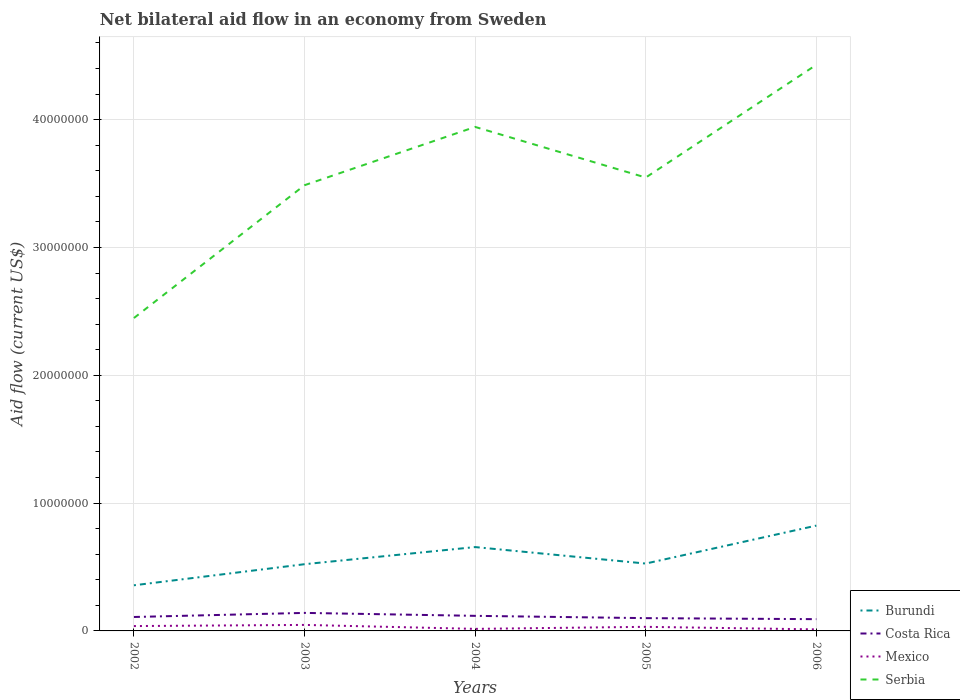Does the line corresponding to Serbia intersect with the line corresponding to Costa Rica?
Your answer should be compact. No. Is the number of lines equal to the number of legend labels?
Keep it short and to the point. Yes. Across all years, what is the maximum net bilateral aid flow in Costa Rica?
Offer a terse response. 9.20e+05. What is the total net bilateral aid flow in Mexico in the graph?
Offer a terse response. 4.00e+04. What is the difference between the highest and the second highest net bilateral aid flow in Mexico?
Offer a terse response. 3.50e+05. Is the net bilateral aid flow in Burundi strictly greater than the net bilateral aid flow in Serbia over the years?
Give a very brief answer. Yes. What is the difference between two consecutive major ticks on the Y-axis?
Make the answer very short. 1.00e+07. Does the graph contain grids?
Your response must be concise. Yes. Where does the legend appear in the graph?
Make the answer very short. Bottom right. What is the title of the graph?
Make the answer very short. Net bilateral aid flow in an economy from Sweden. Does "Central Europe" appear as one of the legend labels in the graph?
Provide a succinct answer. No. What is the Aid flow (current US$) of Burundi in 2002?
Your response must be concise. 3.57e+06. What is the Aid flow (current US$) in Costa Rica in 2002?
Ensure brevity in your answer.  1.09e+06. What is the Aid flow (current US$) in Serbia in 2002?
Provide a short and direct response. 2.45e+07. What is the Aid flow (current US$) of Burundi in 2003?
Your answer should be very brief. 5.22e+06. What is the Aid flow (current US$) of Costa Rica in 2003?
Give a very brief answer. 1.41e+06. What is the Aid flow (current US$) of Mexico in 2003?
Your answer should be compact. 4.70e+05. What is the Aid flow (current US$) of Serbia in 2003?
Provide a short and direct response. 3.49e+07. What is the Aid flow (current US$) of Burundi in 2004?
Keep it short and to the point. 6.56e+06. What is the Aid flow (current US$) in Costa Rica in 2004?
Provide a short and direct response. 1.18e+06. What is the Aid flow (current US$) in Serbia in 2004?
Ensure brevity in your answer.  3.94e+07. What is the Aid flow (current US$) of Burundi in 2005?
Your answer should be compact. 5.27e+06. What is the Aid flow (current US$) in Costa Rica in 2005?
Keep it short and to the point. 1.00e+06. What is the Aid flow (current US$) of Serbia in 2005?
Provide a short and direct response. 3.55e+07. What is the Aid flow (current US$) of Burundi in 2006?
Your answer should be compact. 8.24e+06. What is the Aid flow (current US$) in Costa Rica in 2006?
Your response must be concise. 9.20e+05. What is the Aid flow (current US$) of Serbia in 2006?
Your answer should be compact. 4.43e+07. Across all years, what is the maximum Aid flow (current US$) in Burundi?
Offer a terse response. 8.24e+06. Across all years, what is the maximum Aid flow (current US$) in Costa Rica?
Your answer should be compact. 1.41e+06. Across all years, what is the maximum Aid flow (current US$) of Mexico?
Your answer should be very brief. 4.70e+05. Across all years, what is the maximum Aid flow (current US$) of Serbia?
Your answer should be compact. 4.43e+07. Across all years, what is the minimum Aid flow (current US$) in Burundi?
Provide a succinct answer. 3.57e+06. Across all years, what is the minimum Aid flow (current US$) of Costa Rica?
Make the answer very short. 9.20e+05. Across all years, what is the minimum Aid flow (current US$) of Mexico?
Your response must be concise. 1.20e+05. Across all years, what is the minimum Aid flow (current US$) in Serbia?
Your answer should be very brief. 2.45e+07. What is the total Aid flow (current US$) of Burundi in the graph?
Give a very brief answer. 2.89e+07. What is the total Aid flow (current US$) of Costa Rica in the graph?
Offer a very short reply. 5.60e+06. What is the total Aid flow (current US$) in Mexico in the graph?
Offer a very short reply. 1.45e+06. What is the total Aid flow (current US$) of Serbia in the graph?
Offer a very short reply. 1.79e+08. What is the difference between the Aid flow (current US$) of Burundi in 2002 and that in 2003?
Your response must be concise. -1.65e+06. What is the difference between the Aid flow (current US$) in Costa Rica in 2002 and that in 2003?
Keep it short and to the point. -3.20e+05. What is the difference between the Aid flow (current US$) in Mexico in 2002 and that in 2003?
Provide a short and direct response. -9.00e+04. What is the difference between the Aid flow (current US$) in Serbia in 2002 and that in 2003?
Provide a succinct answer. -1.04e+07. What is the difference between the Aid flow (current US$) in Burundi in 2002 and that in 2004?
Your response must be concise. -2.99e+06. What is the difference between the Aid flow (current US$) of Costa Rica in 2002 and that in 2004?
Your response must be concise. -9.00e+04. What is the difference between the Aid flow (current US$) of Serbia in 2002 and that in 2004?
Ensure brevity in your answer.  -1.50e+07. What is the difference between the Aid flow (current US$) in Burundi in 2002 and that in 2005?
Offer a terse response. -1.70e+06. What is the difference between the Aid flow (current US$) of Serbia in 2002 and that in 2005?
Ensure brevity in your answer.  -1.10e+07. What is the difference between the Aid flow (current US$) of Burundi in 2002 and that in 2006?
Offer a very short reply. -4.67e+06. What is the difference between the Aid flow (current US$) in Mexico in 2002 and that in 2006?
Make the answer very short. 2.60e+05. What is the difference between the Aid flow (current US$) in Serbia in 2002 and that in 2006?
Provide a short and direct response. -1.98e+07. What is the difference between the Aid flow (current US$) of Burundi in 2003 and that in 2004?
Your answer should be compact. -1.34e+06. What is the difference between the Aid flow (current US$) in Mexico in 2003 and that in 2004?
Your response must be concise. 3.10e+05. What is the difference between the Aid flow (current US$) in Serbia in 2003 and that in 2004?
Give a very brief answer. -4.56e+06. What is the difference between the Aid flow (current US$) in Burundi in 2003 and that in 2005?
Your answer should be very brief. -5.00e+04. What is the difference between the Aid flow (current US$) of Serbia in 2003 and that in 2005?
Keep it short and to the point. -6.00e+05. What is the difference between the Aid flow (current US$) in Burundi in 2003 and that in 2006?
Make the answer very short. -3.02e+06. What is the difference between the Aid flow (current US$) in Serbia in 2003 and that in 2006?
Your response must be concise. -9.42e+06. What is the difference between the Aid flow (current US$) in Burundi in 2004 and that in 2005?
Ensure brevity in your answer.  1.29e+06. What is the difference between the Aid flow (current US$) of Mexico in 2004 and that in 2005?
Your answer should be compact. -1.60e+05. What is the difference between the Aid flow (current US$) of Serbia in 2004 and that in 2005?
Give a very brief answer. 3.96e+06. What is the difference between the Aid flow (current US$) in Burundi in 2004 and that in 2006?
Provide a short and direct response. -1.68e+06. What is the difference between the Aid flow (current US$) in Serbia in 2004 and that in 2006?
Give a very brief answer. -4.86e+06. What is the difference between the Aid flow (current US$) of Burundi in 2005 and that in 2006?
Your response must be concise. -2.97e+06. What is the difference between the Aid flow (current US$) in Mexico in 2005 and that in 2006?
Make the answer very short. 2.00e+05. What is the difference between the Aid flow (current US$) of Serbia in 2005 and that in 2006?
Offer a terse response. -8.82e+06. What is the difference between the Aid flow (current US$) of Burundi in 2002 and the Aid flow (current US$) of Costa Rica in 2003?
Your answer should be very brief. 2.16e+06. What is the difference between the Aid flow (current US$) in Burundi in 2002 and the Aid flow (current US$) in Mexico in 2003?
Provide a succinct answer. 3.10e+06. What is the difference between the Aid flow (current US$) in Burundi in 2002 and the Aid flow (current US$) in Serbia in 2003?
Your response must be concise. -3.13e+07. What is the difference between the Aid flow (current US$) in Costa Rica in 2002 and the Aid flow (current US$) in Mexico in 2003?
Your answer should be very brief. 6.20e+05. What is the difference between the Aid flow (current US$) in Costa Rica in 2002 and the Aid flow (current US$) in Serbia in 2003?
Give a very brief answer. -3.38e+07. What is the difference between the Aid flow (current US$) in Mexico in 2002 and the Aid flow (current US$) in Serbia in 2003?
Provide a succinct answer. -3.45e+07. What is the difference between the Aid flow (current US$) of Burundi in 2002 and the Aid flow (current US$) of Costa Rica in 2004?
Make the answer very short. 2.39e+06. What is the difference between the Aid flow (current US$) of Burundi in 2002 and the Aid flow (current US$) of Mexico in 2004?
Ensure brevity in your answer.  3.41e+06. What is the difference between the Aid flow (current US$) in Burundi in 2002 and the Aid flow (current US$) in Serbia in 2004?
Provide a succinct answer. -3.59e+07. What is the difference between the Aid flow (current US$) of Costa Rica in 2002 and the Aid flow (current US$) of Mexico in 2004?
Offer a terse response. 9.30e+05. What is the difference between the Aid flow (current US$) of Costa Rica in 2002 and the Aid flow (current US$) of Serbia in 2004?
Provide a short and direct response. -3.83e+07. What is the difference between the Aid flow (current US$) in Mexico in 2002 and the Aid flow (current US$) in Serbia in 2004?
Your answer should be compact. -3.90e+07. What is the difference between the Aid flow (current US$) in Burundi in 2002 and the Aid flow (current US$) in Costa Rica in 2005?
Your answer should be compact. 2.57e+06. What is the difference between the Aid flow (current US$) in Burundi in 2002 and the Aid flow (current US$) in Mexico in 2005?
Make the answer very short. 3.25e+06. What is the difference between the Aid flow (current US$) of Burundi in 2002 and the Aid flow (current US$) of Serbia in 2005?
Ensure brevity in your answer.  -3.19e+07. What is the difference between the Aid flow (current US$) of Costa Rica in 2002 and the Aid flow (current US$) of Mexico in 2005?
Provide a succinct answer. 7.70e+05. What is the difference between the Aid flow (current US$) of Costa Rica in 2002 and the Aid flow (current US$) of Serbia in 2005?
Offer a very short reply. -3.44e+07. What is the difference between the Aid flow (current US$) in Mexico in 2002 and the Aid flow (current US$) in Serbia in 2005?
Offer a terse response. -3.51e+07. What is the difference between the Aid flow (current US$) of Burundi in 2002 and the Aid flow (current US$) of Costa Rica in 2006?
Offer a terse response. 2.65e+06. What is the difference between the Aid flow (current US$) of Burundi in 2002 and the Aid flow (current US$) of Mexico in 2006?
Provide a short and direct response. 3.45e+06. What is the difference between the Aid flow (current US$) of Burundi in 2002 and the Aid flow (current US$) of Serbia in 2006?
Offer a very short reply. -4.07e+07. What is the difference between the Aid flow (current US$) of Costa Rica in 2002 and the Aid flow (current US$) of Mexico in 2006?
Your answer should be very brief. 9.70e+05. What is the difference between the Aid flow (current US$) of Costa Rica in 2002 and the Aid flow (current US$) of Serbia in 2006?
Make the answer very short. -4.32e+07. What is the difference between the Aid flow (current US$) in Mexico in 2002 and the Aid flow (current US$) in Serbia in 2006?
Offer a terse response. -4.39e+07. What is the difference between the Aid flow (current US$) in Burundi in 2003 and the Aid flow (current US$) in Costa Rica in 2004?
Give a very brief answer. 4.04e+06. What is the difference between the Aid flow (current US$) in Burundi in 2003 and the Aid flow (current US$) in Mexico in 2004?
Your answer should be very brief. 5.06e+06. What is the difference between the Aid flow (current US$) of Burundi in 2003 and the Aid flow (current US$) of Serbia in 2004?
Your answer should be very brief. -3.42e+07. What is the difference between the Aid flow (current US$) of Costa Rica in 2003 and the Aid flow (current US$) of Mexico in 2004?
Provide a short and direct response. 1.25e+06. What is the difference between the Aid flow (current US$) in Costa Rica in 2003 and the Aid flow (current US$) in Serbia in 2004?
Make the answer very short. -3.80e+07. What is the difference between the Aid flow (current US$) of Mexico in 2003 and the Aid flow (current US$) of Serbia in 2004?
Your response must be concise. -3.90e+07. What is the difference between the Aid flow (current US$) of Burundi in 2003 and the Aid flow (current US$) of Costa Rica in 2005?
Ensure brevity in your answer.  4.22e+06. What is the difference between the Aid flow (current US$) in Burundi in 2003 and the Aid flow (current US$) in Mexico in 2005?
Your answer should be compact. 4.90e+06. What is the difference between the Aid flow (current US$) in Burundi in 2003 and the Aid flow (current US$) in Serbia in 2005?
Make the answer very short. -3.02e+07. What is the difference between the Aid flow (current US$) of Costa Rica in 2003 and the Aid flow (current US$) of Mexico in 2005?
Provide a succinct answer. 1.09e+06. What is the difference between the Aid flow (current US$) of Costa Rica in 2003 and the Aid flow (current US$) of Serbia in 2005?
Give a very brief answer. -3.41e+07. What is the difference between the Aid flow (current US$) in Mexico in 2003 and the Aid flow (current US$) in Serbia in 2005?
Provide a short and direct response. -3.50e+07. What is the difference between the Aid flow (current US$) in Burundi in 2003 and the Aid flow (current US$) in Costa Rica in 2006?
Keep it short and to the point. 4.30e+06. What is the difference between the Aid flow (current US$) of Burundi in 2003 and the Aid flow (current US$) of Mexico in 2006?
Your answer should be very brief. 5.10e+06. What is the difference between the Aid flow (current US$) in Burundi in 2003 and the Aid flow (current US$) in Serbia in 2006?
Provide a short and direct response. -3.91e+07. What is the difference between the Aid flow (current US$) in Costa Rica in 2003 and the Aid flow (current US$) in Mexico in 2006?
Your answer should be compact. 1.29e+06. What is the difference between the Aid flow (current US$) in Costa Rica in 2003 and the Aid flow (current US$) in Serbia in 2006?
Ensure brevity in your answer.  -4.29e+07. What is the difference between the Aid flow (current US$) of Mexico in 2003 and the Aid flow (current US$) of Serbia in 2006?
Offer a terse response. -4.38e+07. What is the difference between the Aid flow (current US$) in Burundi in 2004 and the Aid flow (current US$) in Costa Rica in 2005?
Offer a very short reply. 5.56e+06. What is the difference between the Aid flow (current US$) in Burundi in 2004 and the Aid flow (current US$) in Mexico in 2005?
Give a very brief answer. 6.24e+06. What is the difference between the Aid flow (current US$) in Burundi in 2004 and the Aid flow (current US$) in Serbia in 2005?
Your answer should be compact. -2.89e+07. What is the difference between the Aid flow (current US$) in Costa Rica in 2004 and the Aid flow (current US$) in Mexico in 2005?
Provide a succinct answer. 8.60e+05. What is the difference between the Aid flow (current US$) in Costa Rica in 2004 and the Aid flow (current US$) in Serbia in 2005?
Your response must be concise. -3.43e+07. What is the difference between the Aid flow (current US$) of Mexico in 2004 and the Aid flow (current US$) of Serbia in 2005?
Provide a short and direct response. -3.53e+07. What is the difference between the Aid flow (current US$) in Burundi in 2004 and the Aid flow (current US$) in Costa Rica in 2006?
Your response must be concise. 5.64e+06. What is the difference between the Aid flow (current US$) in Burundi in 2004 and the Aid flow (current US$) in Mexico in 2006?
Your response must be concise. 6.44e+06. What is the difference between the Aid flow (current US$) of Burundi in 2004 and the Aid flow (current US$) of Serbia in 2006?
Keep it short and to the point. -3.77e+07. What is the difference between the Aid flow (current US$) in Costa Rica in 2004 and the Aid flow (current US$) in Mexico in 2006?
Provide a short and direct response. 1.06e+06. What is the difference between the Aid flow (current US$) of Costa Rica in 2004 and the Aid flow (current US$) of Serbia in 2006?
Offer a terse response. -4.31e+07. What is the difference between the Aid flow (current US$) in Mexico in 2004 and the Aid flow (current US$) in Serbia in 2006?
Your answer should be very brief. -4.41e+07. What is the difference between the Aid flow (current US$) in Burundi in 2005 and the Aid flow (current US$) in Costa Rica in 2006?
Your answer should be compact. 4.35e+06. What is the difference between the Aid flow (current US$) of Burundi in 2005 and the Aid flow (current US$) of Mexico in 2006?
Your response must be concise. 5.15e+06. What is the difference between the Aid flow (current US$) of Burundi in 2005 and the Aid flow (current US$) of Serbia in 2006?
Make the answer very short. -3.90e+07. What is the difference between the Aid flow (current US$) in Costa Rica in 2005 and the Aid flow (current US$) in Mexico in 2006?
Offer a terse response. 8.80e+05. What is the difference between the Aid flow (current US$) of Costa Rica in 2005 and the Aid flow (current US$) of Serbia in 2006?
Your response must be concise. -4.33e+07. What is the difference between the Aid flow (current US$) in Mexico in 2005 and the Aid flow (current US$) in Serbia in 2006?
Provide a succinct answer. -4.40e+07. What is the average Aid flow (current US$) of Burundi per year?
Make the answer very short. 5.77e+06. What is the average Aid flow (current US$) of Costa Rica per year?
Offer a very short reply. 1.12e+06. What is the average Aid flow (current US$) in Serbia per year?
Your answer should be very brief. 3.57e+07. In the year 2002, what is the difference between the Aid flow (current US$) in Burundi and Aid flow (current US$) in Costa Rica?
Your response must be concise. 2.48e+06. In the year 2002, what is the difference between the Aid flow (current US$) in Burundi and Aid flow (current US$) in Mexico?
Provide a short and direct response. 3.19e+06. In the year 2002, what is the difference between the Aid flow (current US$) of Burundi and Aid flow (current US$) of Serbia?
Your answer should be very brief. -2.09e+07. In the year 2002, what is the difference between the Aid flow (current US$) in Costa Rica and Aid flow (current US$) in Mexico?
Provide a succinct answer. 7.10e+05. In the year 2002, what is the difference between the Aid flow (current US$) in Costa Rica and Aid flow (current US$) in Serbia?
Ensure brevity in your answer.  -2.34e+07. In the year 2002, what is the difference between the Aid flow (current US$) of Mexico and Aid flow (current US$) of Serbia?
Offer a terse response. -2.41e+07. In the year 2003, what is the difference between the Aid flow (current US$) in Burundi and Aid flow (current US$) in Costa Rica?
Your response must be concise. 3.81e+06. In the year 2003, what is the difference between the Aid flow (current US$) of Burundi and Aid flow (current US$) of Mexico?
Offer a very short reply. 4.75e+06. In the year 2003, what is the difference between the Aid flow (current US$) of Burundi and Aid flow (current US$) of Serbia?
Your answer should be very brief. -2.96e+07. In the year 2003, what is the difference between the Aid flow (current US$) in Costa Rica and Aid flow (current US$) in Mexico?
Give a very brief answer. 9.40e+05. In the year 2003, what is the difference between the Aid flow (current US$) of Costa Rica and Aid flow (current US$) of Serbia?
Provide a succinct answer. -3.35e+07. In the year 2003, what is the difference between the Aid flow (current US$) in Mexico and Aid flow (current US$) in Serbia?
Your answer should be compact. -3.44e+07. In the year 2004, what is the difference between the Aid flow (current US$) of Burundi and Aid flow (current US$) of Costa Rica?
Offer a terse response. 5.38e+06. In the year 2004, what is the difference between the Aid flow (current US$) in Burundi and Aid flow (current US$) in Mexico?
Your response must be concise. 6.40e+06. In the year 2004, what is the difference between the Aid flow (current US$) of Burundi and Aid flow (current US$) of Serbia?
Provide a short and direct response. -3.29e+07. In the year 2004, what is the difference between the Aid flow (current US$) in Costa Rica and Aid flow (current US$) in Mexico?
Provide a succinct answer. 1.02e+06. In the year 2004, what is the difference between the Aid flow (current US$) in Costa Rica and Aid flow (current US$) in Serbia?
Give a very brief answer. -3.82e+07. In the year 2004, what is the difference between the Aid flow (current US$) of Mexico and Aid flow (current US$) of Serbia?
Ensure brevity in your answer.  -3.93e+07. In the year 2005, what is the difference between the Aid flow (current US$) of Burundi and Aid flow (current US$) of Costa Rica?
Make the answer very short. 4.27e+06. In the year 2005, what is the difference between the Aid flow (current US$) of Burundi and Aid flow (current US$) of Mexico?
Provide a succinct answer. 4.95e+06. In the year 2005, what is the difference between the Aid flow (current US$) of Burundi and Aid flow (current US$) of Serbia?
Keep it short and to the point. -3.02e+07. In the year 2005, what is the difference between the Aid flow (current US$) of Costa Rica and Aid flow (current US$) of Mexico?
Your answer should be very brief. 6.80e+05. In the year 2005, what is the difference between the Aid flow (current US$) of Costa Rica and Aid flow (current US$) of Serbia?
Offer a very short reply. -3.45e+07. In the year 2005, what is the difference between the Aid flow (current US$) in Mexico and Aid flow (current US$) in Serbia?
Ensure brevity in your answer.  -3.52e+07. In the year 2006, what is the difference between the Aid flow (current US$) of Burundi and Aid flow (current US$) of Costa Rica?
Your answer should be very brief. 7.32e+06. In the year 2006, what is the difference between the Aid flow (current US$) in Burundi and Aid flow (current US$) in Mexico?
Offer a very short reply. 8.12e+06. In the year 2006, what is the difference between the Aid flow (current US$) of Burundi and Aid flow (current US$) of Serbia?
Provide a succinct answer. -3.60e+07. In the year 2006, what is the difference between the Aid flow (current US$) in Costa Rica and Aid flow (current US$) in Serbia?
Keep it short and to the point. -4.34e+07. In the year 2006, what is the difference between the Aid flow (current US$) of Mexico and Aid flow (current US$) of Serbia?
Give a very brief answer. -4.42e+07. What is the ratio of the Aid flow (current US$) in Burundi in 2002 to that in 2003?
Give a very brief answer. 0.68. What is the ratio of the Aid flow (current US$) of Costa Rica in 2002 to that in 2003?
Your answer should be very brief. 0.77. What is the ratio of the Aid flow (current US$) of Mexico in 2002 to that in 2003?
Your answer should be very brief. 0.81. What is the ratio of the Aid flow (current US$) of Serbia in 2002 to that in 2003?
Your answer should be compact. 0.7. What is the ratio of the Aid flow (current US$) in Burundi in 2002 to that in 2004?
Your response must be concise. 0.54. What is the ratio of the Aid flow (current US$) of Costa Rica in 2002 to that in 2004?
Offer a very short reply. 0.92. What is the ratio of the Aid flow (current US$) in Mexico in 2002 to that in 2004?
Provide a succinct answer. 2.38. What is the ratio of the Aid flow (current US$) in Serbia in 2002 to that in 2004?
Ensure brevity in your answer.  0.62. What is the ratio of the Aid flow (current US$) of Burundi in 2002 to that in 2005?
Give a very brief answer. 0.68. What is the ratio of the Aid flow (current US$) of Costa Rica in 2002 to that in 2005?
Your answer should be compact. 1.09. What is the ratio of the Aid flow (current US$) of Mexico in 2002 to that in 2005?
Give a very brief answer. 1.19. What is the ratio of the Aid flow (current US$) of Serbia in 2002 to that in 2005?
Provide a succinct answer. 0.69. What is the ratio of the Aid flow (current US$) in Burundi in 2002 to that in 2006?
Provide a short and direct response. 0.43. What is the ratio of the Aid flow (current US$) in Costa Rica in 2002 to that in 2006?
Keep it short and to the point. 1.18. What is the ratio of the Aid flow (current US$) in Mexico in 2002 to that in 2006?
Offer a terse response. 3.17. What is the ratio of the Aid flow (current US$) in Serbia in 2002 to that in 2006?
Provide a short and direct response. 0.55. What is the ratio of the Aid flow (current US$) of Burundi in 2003 to that in 2004?
Make the answer very short. 0.8. What is the ratio of the Aid flow (current US$) of Costa Rica in 2003 to that in 2004?
Give a very brief answer. 1.19. What is the ratio of the Aid flow (current US$) in Mexico in 2003 to that in 2004?
Offer a terse response. 2.94. What is the ratio of the Aid flow (current US$) in Serbia in 2003 to that in 2004?
Your answer should be very brief. 0.88. What is the ratio of the Aid flow (current US$) in Burundi in 2003 to that in 2005?
Offer a very short reply. 0.99. What is the ratio of the Aid flow (current US$) of Costa Rica in 2003 to that in 2005?
Your answer should be very brief. 1.41. What is the ratio of the Aid flow (current US$) in Mexico in 2003 to that in 2005?
Keep it short and to the point. 1.47. What is the ratio of the Aid flow (current US$) in Serbia in 2003 to that in 2005?
Keep it short and to the point. 0.98. What is the ratio of the Aid flow (current US$) in Burundi in 2003 to that in 2006?
Ensure brevity in your answer.  0.63. What is the ratio of the Aid flow (current US$) in Costa Rica in 2003 to that in 2006?
Provide a succinct answer. 1.53. What is the ratio of the Aid flow (current US$) of Mexico in 2003 to that in 2006?
Make the answer very short. 3.92. What is the ratio of the Aid flow (current US$) of Serbia in 2003 to that in 2006?
Offer a very short reply. 0.79. What is the ratio of the Aid flow (current US$) of Burundi in 2004 to that in 2005?
Your answer should be compact. 1.24. What is the ratio of the Aid flow (current US$) in Costa Rica in 2004 to that in 2005?
Give a very brief answer. 1.18. What is the ratio of the Aid flow (current US$) of Serbia in 2004 to that in 2005?
Ensure brevity in your answer.  1.11. What is the ratio of the Aid flow (current US$) in Burundi in 2004 to that in 2006?
Offer a terse response. 0.8. What is the ratio of the Aid flow (current US$) of Costa Rica in 2004 to that in 2006?
Offer a very short reply. 1.28. What is the ratio of the Aid flow (current US$) in Serbia in 2004 to that in 2006?
Your answer should be very brief. 0.89. What is the ratio of the Aid flow (current US$) of Burundi in 2005 to that in 2006?
Offer a terse response. 0.64. What is the ratio of the Aid flow (current US$) of Costa Rica in 2005 to that in 2006?
Offer a very short reply. 1.09. What is the ratio of the Aid flow (current US$) in Mexico in 2005 to that in 2006?
Provide a succinct answer. 2.67. What is the ratio of the Aid flow (current US$) in Serbia in 2005 to that in 2006?
Ensure brevity in your answer.  0.8. What is the difference between the highest and the second highest Aid flow (current US$) of Burundi?
Make the answer very short. 1.68e+06. What is the difference between the highest and the second highest Aid flow (current US$) of Costa Rica?
Offer a very short reply. 2.30e+05. What is the difference between the highest and the second highest Aid flow (current US$) of Serbia?
Offer a very short reply. 4.86e+06. What is the difference between the highest and the lowest Aid flow (current US$) in Burundi?
Provide a succinct answer. 4.67e+06. What is the difference between the highest and the lowest Aid flow (current US$) in Costa Rica?
Provide a succinct answer. 4.90e+05. What is the difference between the highest and the lowest Aid flow (current US$) of Mexico?
Keep it short and to the point. 3.50e+05. What is the difference between the highest and the lowest Aid flow (current US$) of Serbia?
Your response must be concise. 1.98e+07. 